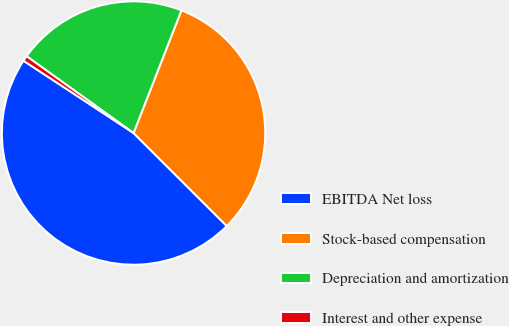<chart> <loc_0><loc_0><loc_500><loc_500><pie_chart><fcel>EBITDA Net loss<fcel>Stock-based compensation<fcel>Depreciation and amortization<fcel>Interest and other expense<nl><fcel>46.77%<fcel>31.56%<fcel>21.01%<fcel>0.66%<nl></chart> 